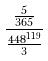Convert formula to latex. <formula><loc_0><loc_0><loc_500><loc_500>\frac { \frac { 5 } { 3 6 5 } } { \frac { 4 4 8 ^ { 1 1 9 } } { 3 } }</formula> 